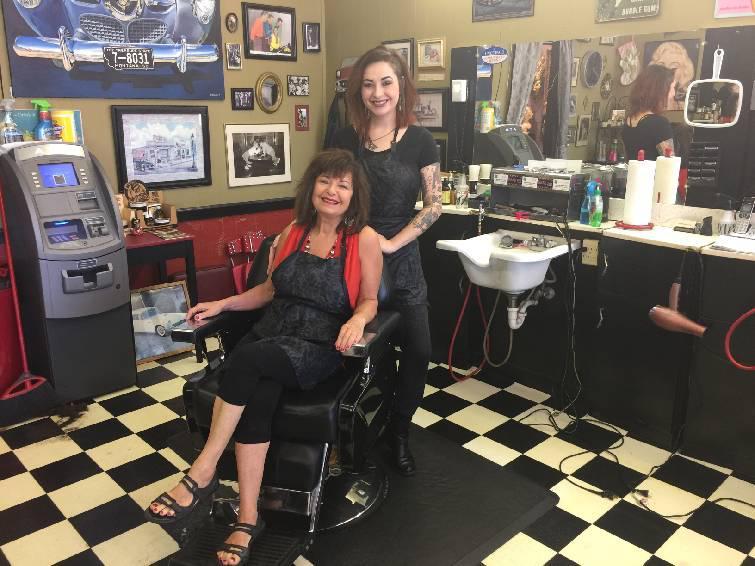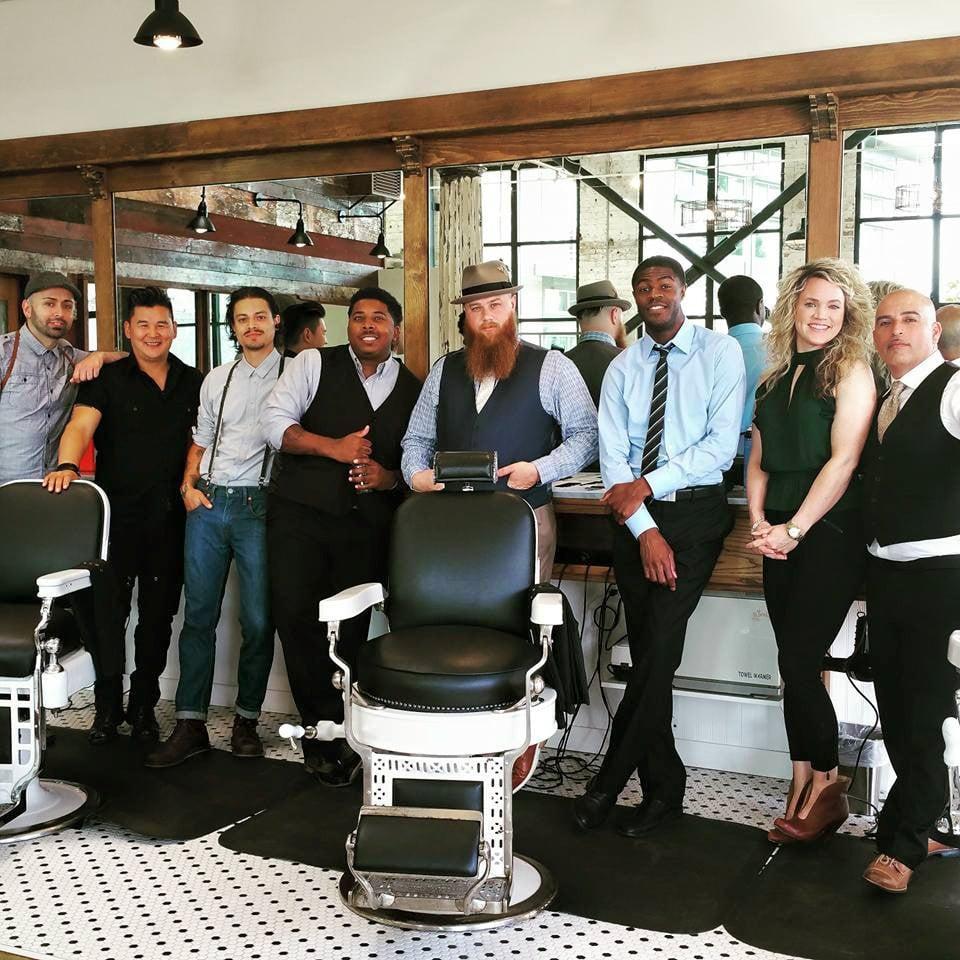The first image is the image on the left, the second image is the image on the right. For the images displayed, is the sentence "In one image a single barber is working with a customer, while a person stands at a store counter in the second image." factually correct? Answer yes or no. No. 